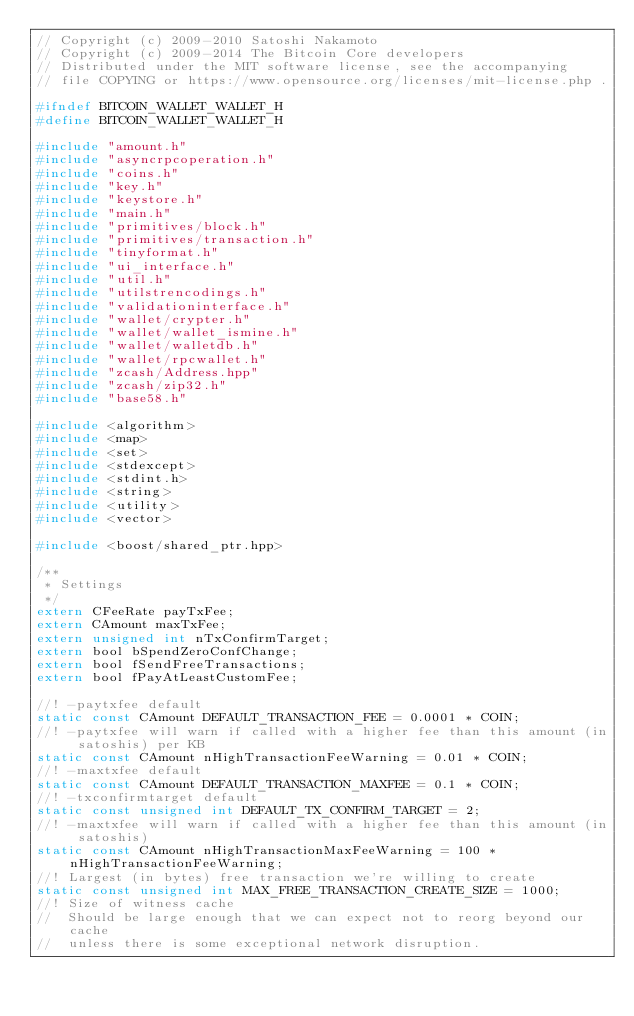Convert code to text. <code><loc_0><loc_0><loc_500><loc_500><_C_>// Copyright (c) 2009-2010 Satoshi Nakamoto
// Copyright (c) 2009-2014 The Bitcoin Core developers
// Distributed under the MIT software license, see the accompanying
// file COPYING or https://www.opensource.org/licenses/mit-license.php .

#ifndef BITCOIN_WALLET_WALLET_H
#define BITCOIN_WALLET_WALLET_H

#include "amount.h"
#include "asyncrpcoperation.h"
#include "coins.h"
#include "key.h"
#include "keystore.h"
#include "main.h"
#include "primitives/block.h"
#include "primitives/transaction.h"
#include "tinyformat.h"
#include "ui_interface.h"
#include "util.h"
#include "utilstrencodings.h"
#include "validationinterface.h"
#include "wallet/crypter.h"
#include "wallet/wallet_ismine.h"
#include "wallet/walletdb.h"
#include "wallet/rpcwallet.h"
#include "zcash/Address.hpp"
#include "zcash/zip32.h"
#include "base58.h"

#include <algorithm>
#include <map>
#include <set>
#include <stdexcept>
#include <stdint.h>
#include <string>
#include <utility>
#include <vector>

#include <boost/shared_ptr.hpp>

/**
 * Settings
 */
extern CFeeRate payTxFee;
extern CAmount maxTxFee;
extern unsigned int nTxConfirmTarget;
extern bool bSpendZeroConfChange;
extern bool fSendFreeTransactions;
extern bool fPayAtLeastCustomFee;

//! -paytxfee default
static const CAmount DEFAULT_TRANSACTION_FEE = 0.0001 * COIN;
//! -paytxfee will warn if called with a higher fee than this amount (in satoshis) per KB
static const CAmount nHighTransactionFeeWarning = 0.01 * COIN;
//! -maxtxfee default
static const CAmount DEFAULT_TRANSACTION_MAXFEE = 0.1 * COIN;
//! -txconfirmtarget default
static const unsigned int DEFAULT_TX_CONFIRM_TARGET = 2;
//! -maxtxfee will warn if called with a higher fee than this amount (in satoshis)
static const CAmount nHighTransactionMaxFeeWarning = 100 * nHighTransactionFeeWarning;
//! Largest (in bytes) free transaction we're willing to create
static const unsigned int MAX_FREE_TRANSACTION_CREATE_SIZE = 1000;
//! Size of witness cache
//  Should be large enough that we can expect not to reorg beyond our cache
//  unless there is some exceptional network disruption.</code> 